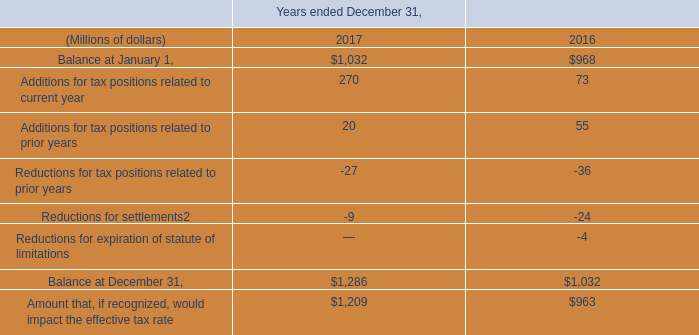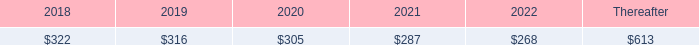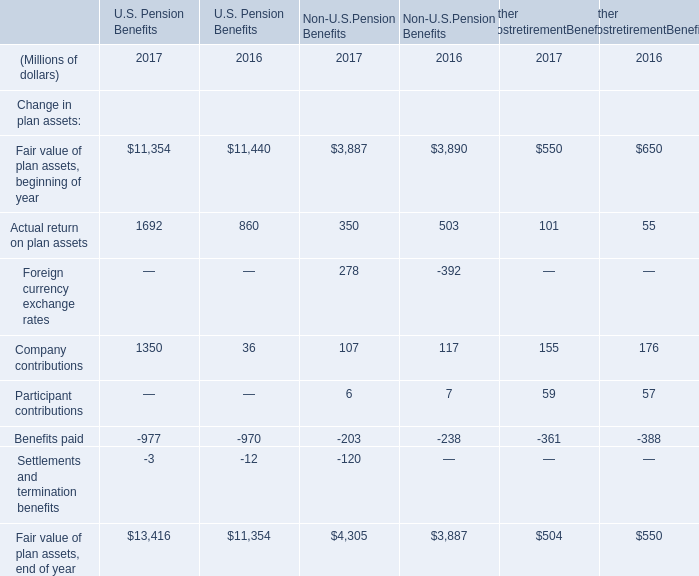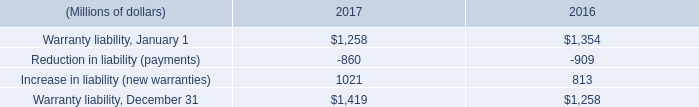In the year/section with the most Fair value of plan assets, beginning of year, what is the growth rate of Actual return on plan assets? 
Computations: ((((1692 + 350) + 101) - ((860 + 503) + 55)) / ((860 + 503) + 55))
Answer: 0.51128. 